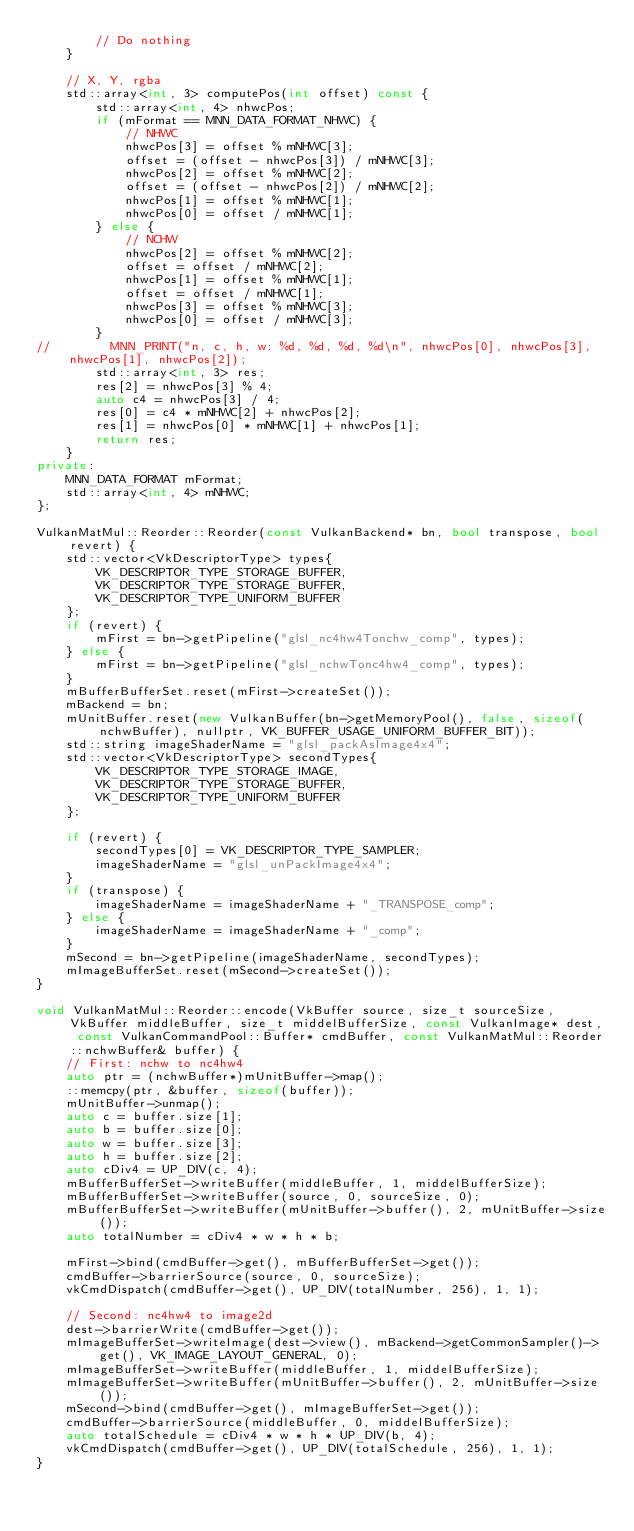Convert code to text. <code><loc_0><loc_0><loc_500><loc_500><_C++_>        // Do nothing
    }

    // X, Y, rgba
    std::array<int, 3> computePos(int offset) const {
        std::array<int, 4> nhwcPos;
        if (mFormat == MNN_DATA_FORMAT_NHWC) {
            // NHWC
            nhwcPos[3] = offset % mNHWC[3];
            offset = (offset - nhwcPos[3]) / mNHWC[3];
            nhwcPos[2] = offset % mNHWC[2];
            offset = (offset - nhwcPos[2]) / mNHWC[2];
            nhwcPos[1] = offset % mNHWC[1];
            nhwcPos[0] = offset / mNHWC[1];
        } else {
            // NCHW
            nhwcPos[2] = offset % mNHWC[2];
            offset = offset / mNHWC[2];
            nhwcPos[1] = offset % mNHWC[1];
            offset = offset / mNHWC[1];
            nhwcPos[3] = offset % mNHWC[3];
            nhwcPos[0] = offset / mNHWC[3];
        }
//        MNN_PRINT("n, c, h, w: %d, %d, %d, %d\n", nhwcPos[0], nhwcPos[3], nhwcPos[1], nhwcPos[2]);
        std::array<int, 3> res;
        res[2] = nhwcPos[3] % 4;
        auto c4 = nhwcPos[3] / 4;
        res[0] = c4 * mNHWC[2] + nhwcPos[2];
        res[1] = nhwcPos[0] * mNHWC[1] + nhwcPos[1];
        return res;
    }
private:
    MNN_DATA_FORMAT mFormat;
    std::array<int, 4> mNHWC;
};

VulkanMatMul::Reorder::Reorder(const VulkanBackend* bn, bool transpose, bool revert) {
    std::vector<VkDescriptorType> types{
        VK_DESCRIPTOR_TYPE_STORAGE_BUFFER,
        VK_DESCRIPTOR_TYPE_STORAGE_BUFFER,
        VK_DESCRIPTOR_TYPE_UNIFORM_BUFFER
    };
    if (revert) {
        mFirst = bn->getPipeline("glsl_nc4hw4Tonchw_comp", types);
    } else {
        mFirst = bn->getPipeline("glsl_nchwTonc4hw4_comp", types);
    }
    mBufferBufferSet.reset(mFirst->createSet());
    mBackend = bn;
    mUnitBuffer.reset(new VulkanBuffer(bn->getMemoryPool(), false, sizeof(nchwBuffer), nullptr, VK_BUFFER_USAGE_UNIFORM_BUFFER_BIT));
    std::string imageShaderName = "glsl_packAsImage4x4";
    std::vector<VkDescriptorType> secondTypes{
        VK_DESCRIPTOR_TYPE_STORAGE_IMAGE,
        VK_DESCRIPTOR_TYPE_STORAGE_BUFFER,
        VK_DESCRIPTOR_TYPE_UNIFORM_BUFFER
    };

    if (revert) {
        secondTypes[0] = VK_DESCRIPTOR_TYPE_SAMPLER;
        imageShaderName = "glsl_unPackImage4x4";
    }
    if (transpose) {
        imageShaderName = imageShaderName + "_TRANSPOSE_comp";
    } else {
        imageShaderName = imageShaderName + "_comp";
    }
    mSecond = bn->getPipeline(imageShaderName, secondTypes);
    mImageBufferSet.reset(mSecond->createSet());
}

void VulkanMatMul::Reorder::encode(VkBuffer source, size_t sourceSize, VkBuffer middleBuffer, size_t middelBufferSize, const VulkanImage* dest, const VulkanCommandPool::Buffer* cmdBuffer, const VulkanMatMul::Reorder::nchwBuffer& buffer) {
    // First: nchw to nc4hw4
    auto ptr = (nchwBuffer*)mUnitBuffer->map();
    ::memcpy(ptr, &buffer, sizeof(buffer));
    mUnitBuffer->unmap();
    auto c = buffer.size[1];
    auto b = buffer.size[0];
    auto w = buffer.size[3];
    auto h = buffer.size[2];
    auto cDiv4 = UP_DIV(c, 4);
    mBufferBufferSet->writeBuffer(middleBuffer, 1, middelBufferSize);
    mBufferBufferSet->writeBuffer(source, 0, sourceSize, 0);
    mBufferBufferSet->writeBuffer(mUnitBuffer->buffer(), 2, mUnitBuffer->size());
    auto totalNumber = cDiv4 * w * h * b;

    mFirst->bind(cmdBuffer->get(), mBufferBufferSet->get());
    cmdBuffer->barrierSource(source, 0, sourceSize);
    vkCmdDispatch(cmdBuffer->get(), UP_DIV(totalNumber, 256), 1, 1);
    
    // Second: nc4hw4 to image2d
    dest->barrierWrite(cmdBuffer->get());
    mImageBufferSet->writeImage(dest->view(), mBackend->getCommonSampler()->get(), VK_IMAGE_LAYOUT_GENERAL, 0);
    mImageBufferSet->writeBuffer(middleBuffer, 1, middelBufferSize);
    mImageBufferSet->writeBuffer(mUnitBuffer->buffer(), 2, mUnitBuffer->size());
    mSecond->bind(cmdBuffer->get(), mImageBufferSet->get());
    cmdBuffer->barrierSource(middleBuffer, 0, middelBufferSize);
    auto totalSchedule = cDiv4 * w * h * UP_DIV(b, 4);
    vkCmdDispatch(cmdBuffer->get(), UP_DIV(totalSchedule, 256), 1, 1);
}</code> 